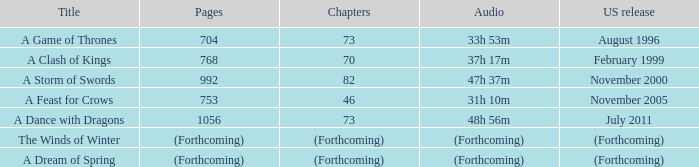Which audio piece is titled a storm of swords? 47h 37m. 